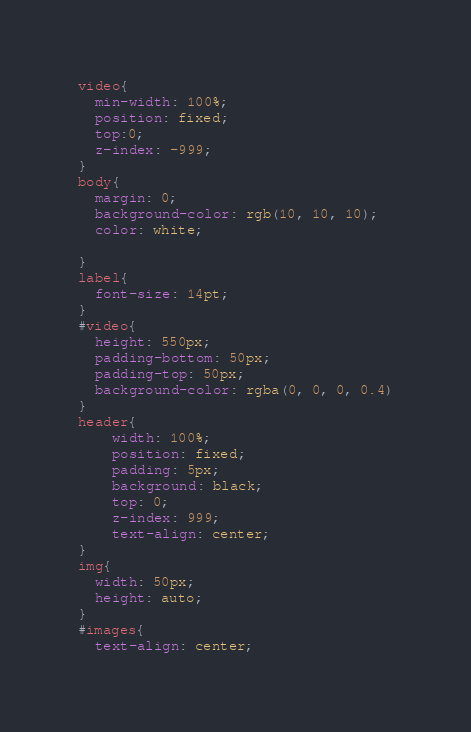Convert code to text. <code><loc_0><loc_0><loc_500><loc_500><_CSS_>video{
  min-width: 100%;
  position: fixed;
  top:0;
  z-index: -999;
}
body{
  margin: 0;
  background-color: rgb(10, 10, 10);
  color: white;

}
label{
  font-size: 14pt;
}
#video{
  height: 550px;
  padding-bottom: 50px;
  padding-top: 50px;
  background-color: rgba(0, 0, 0, 0.4)
}
header{
    width: 100%;
    position: fixed;
    padding: 5px;
    background: black;
    top: 0;
    z-index: 999;
    text-align: center;
}
img{
  width: 50px;
  height: auto;
}
#images{
  text-align: center;</code> 